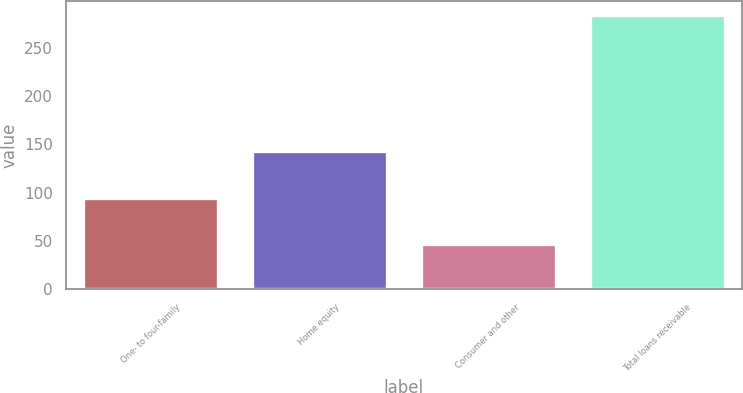Convert chart to OTSL. <chart><loc_0><loc_0><loc_500><loc_500><bar_chart><fcel>One- to four-family<fcel>Home equity<fcel>Consumer and other<fcel>Total loans receivable<nl><fcel>94<fcel>143<fcel>47<fcel>284<nl></chart> 